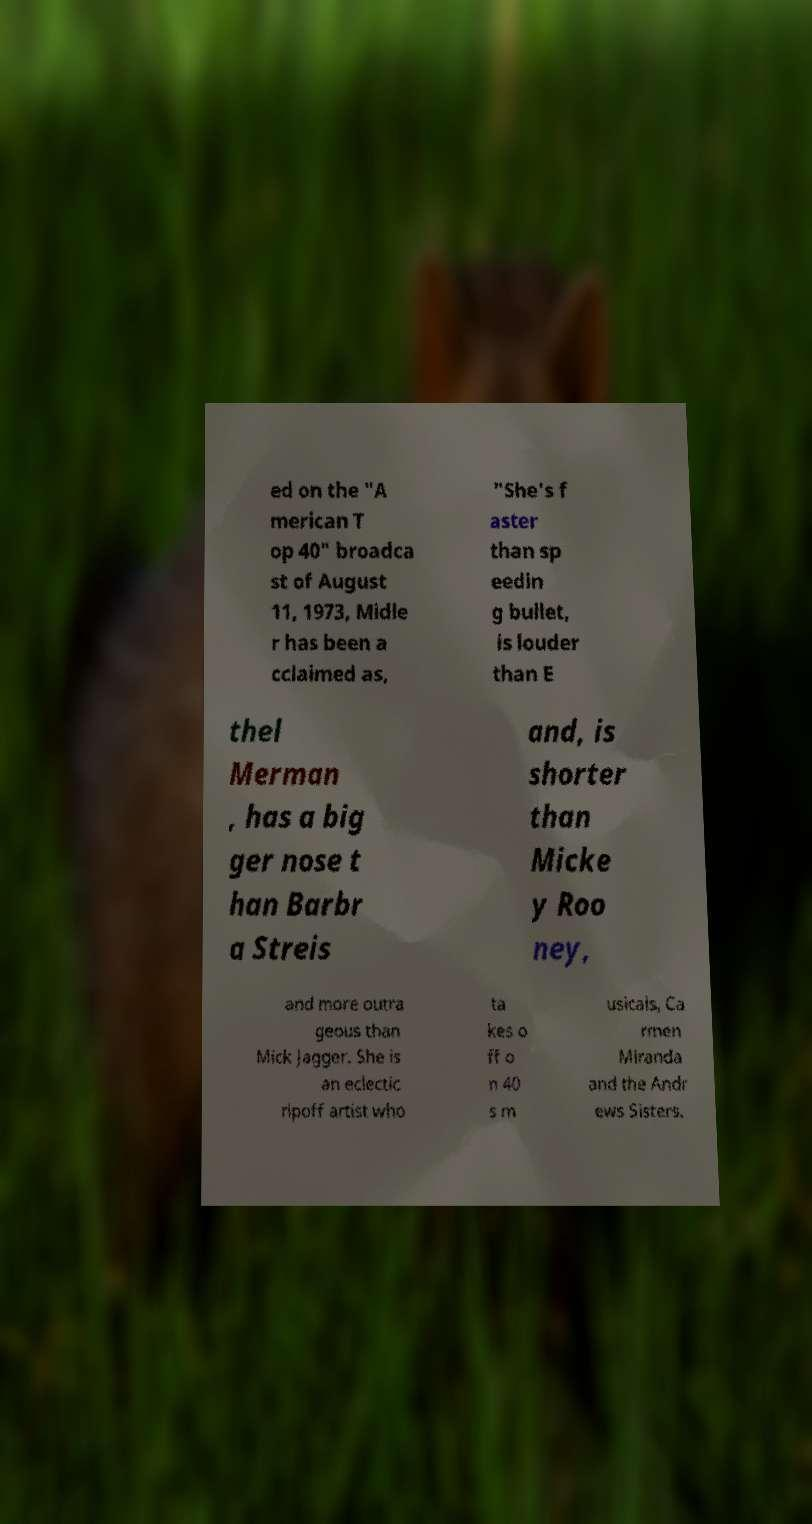Please read and relay the text visible in this image. What does it say? ed on the "A merican T op 40" broadca st of August 11, 1973, Midle r has been a cclaimed as, "She's f aster than sp eedin g bullet, is louder than E thel Merman , has a big ger nose t han Barbr a Streis and, is shorter than Micke y Roo ney, and more outra geous than Mick Jagger. She is an eclectic ripoff artist who ta kes o ff o n 40 s m usicals, Ca rmen Miranda and the Andr ews Sisters. 